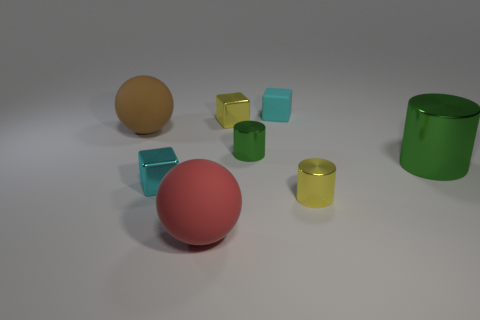What kind of materials do the objects in the image look like they're made from? The objects have distinctive textures suggesting they are made from different materials. The spheres and the cylinder appear to have a shiny, reflective surface, which could indicate they are made of a material such as plastic or polished metal. In contrast, the cubes display a more matte finish, suggesting a possible rubber-like material. 